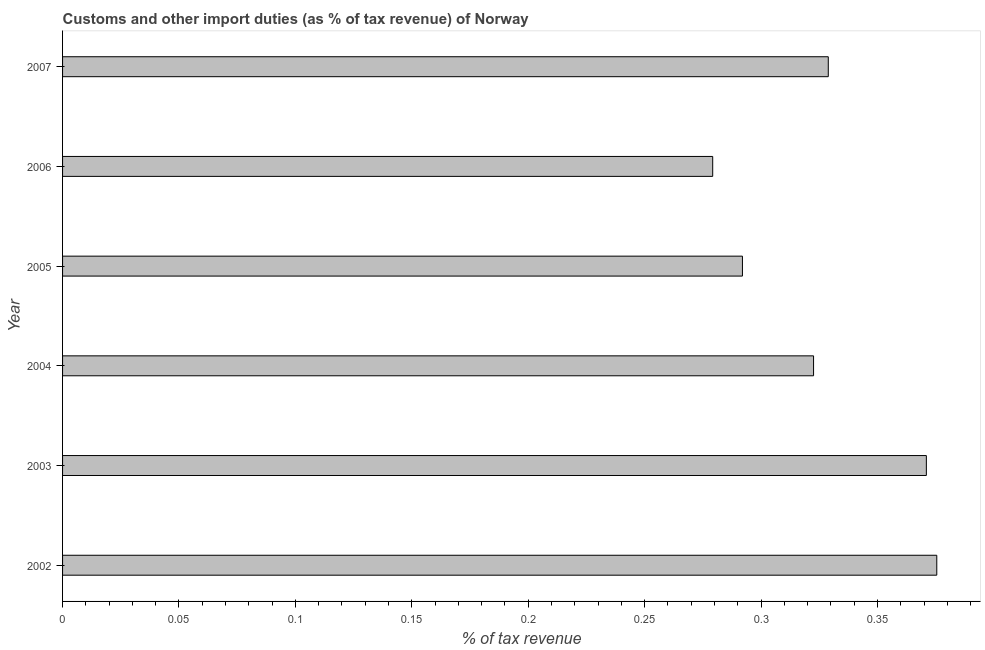What is the title of the graph?
Your response must be concise. Customs and other import duties (as % of tax revenue) of Norway. What is the label or title of the X-axis?
Provide a short and direct response. % of tax revenue. What is the customs and other import duties in 2004?
Keep it short and to the point. 0.32. Across all years, what is the maximum customs and other import duties?
Your answer should be compact. 0.38. Across all years, what is the minimum customs and other import duties?
Keep it short and to the point. 0.28. In which year was the customs and other import duties maximum?
Your response must be concise. 2002. In which year was the customs and other import duties minimum?
Provide a succinct answer. 2006. What is the sum of the customs and other import duties?
Give a very brief answer. 1.97. What is the difference between the customs and other import duties in 2002 and 2004?
Offer a very short reply. 0.05. What is the average customs and other import duties per year?
Give a very brief answer. 0.33. What is the median customs and other import duties?
Give a very brief answer. 0.33. In how many years, is the customs and other import duties greater than 0.2 %?
Provide a short and direct response. 6. Do a majority of the years between 2007 and 2005 (inclusive) have customs and other import duties greater than 0.14 %?
Your answer should be compact. Yes. What is the ratio of the customs and other import duties in 2006 to that in 2007?
Keep it short and to the point. 0.85. What is the difference between the highest and the second highest customs and other import duties?
Offer a very short reply. 0. How many bars are there?
Offer a very short reply. 6. Are all the bars in the graph horizontal?
Provide a succinct answer. Yes. What is the difference between two consecutive major ticks on the X-axis?
Your response must be concise. 0.05. What is the % of tax revenue of 2002?
Keep it short and to the point. 0.38. What is the % of tax revenue in 2003?
Offer a terse response. 0.37. What is the % of tax revenue in 2004?
Make the answer very short. 0.32. What is the % of tax revenue of 2005?
Provide a short and direct response. 0.29. What is the % of tax revenue of 2006?
Your answer should be compact. 0.28. What is the % of tax revenue in 2007?
Your response must be concise. 0.33. What is the difference between the % of tax revenue in 2002 and 2003?
Ensure brevity in your answer.  0. What is the difference between the % of tax revenue in 2002 and 2004?
Ensure brevity in your answer.  0.05. What is the difference between the % of tax revenue in 2002 and 2005?
Keep it short and to the point. 0.08. What is the difference between the % of tax revenue in 2002 and 2006?
Your answer should be compact. 0.1. What is the difference between the % of tax revenue in 2002 and 2007?
Make the answer very short. 0.05. What is the difference between the % of tax revenue in 2003 and 2004?
Offer a very short reply. 0.05. What is the difference between the % of tax revenue in 2003 and 2005?
Your answer should be compact. 0.08. What is the difference between the % of tax revenue in 2003 and 2006?
Offer a terse response. 0.09. What is the difference between the % of tax revenue in 2003 and 2007?
Provide a succinct answer. 0.04. What is the difference between the % of tax revenue in 2004 and 2005?
Your answer should be compact. 0.03. What is the difference between the % of tax revenue in 2004 and 2006?
Offer a very short reply. 0.04. What is the difference between the % of tax revenue in 2004 and 2007?
Ensure brevity in your answer.  -0.01. What is the difference between the % of tax revenue in 2005 and 2006?
Your answer should be very brief. 0.01. What is the difference between the % of tax revenue in 2005 and 2007?
Your answer should be very brief. -0.04. What is the difference between the % of tax revenue in 2006 and 2007?
Offer a terse response. -0.05. What is the ratio of the % of tax revenue in 2002 to that in 2003?
Your answer should be compact. 1.01. What is the ratio of the % of tax revenue in 2002 to that in 2004?
Ensure brevity in your answer.  1.16. What is the ratio of the % of tax revenue in 2002 to that in 2005?
Keep it short and to the point. 1.29. What is the ratio of the % of tax revenue in 2002 to that in 2006?
Your answer should be very brief. 1.34. What is the ratio of the % of tax revenue in 2002 to that in 2007?
Offer a terse response. 1.14. What is the ratio of the % of tax revenue in 2003 to that in 2004?
Make the answer very short. 1.15. What is the ratio of the % of tax revenue in 2003 to that in 2005?
Keep it short and to the point. 1.27. What is the ratio of the % of tax revenue in 2003 to that in 2006?
Provide a short and direct response. 1.33. What is the ratio of the % of tax revenue in 2003 to that in 2007?
Your answer should be compact. 1.13. What is the ratio of the % of tax revenue in 2004 to that in 2005?
Make the answer very short. 1.1. What is the ratio of the % of tax revenue in 2004 to that in 2006?
Offer a very short reply. 1.16. What is the ratio of the % of tax revenue in 2004 to that in 2007?
Offer a very short reply. 0.98. What is the ratio of the % of tax revenue in 2005 to that in 2006?
Your answer should be compact. 1.05. What is the ratio of the % of tax revenue in 2005 to that in 2007?
Your answer should be compact. 0.89. What is the ratio of the % of tax revenue in 2006 to that in 2007?
Your answer should be very brief. 0.85. 